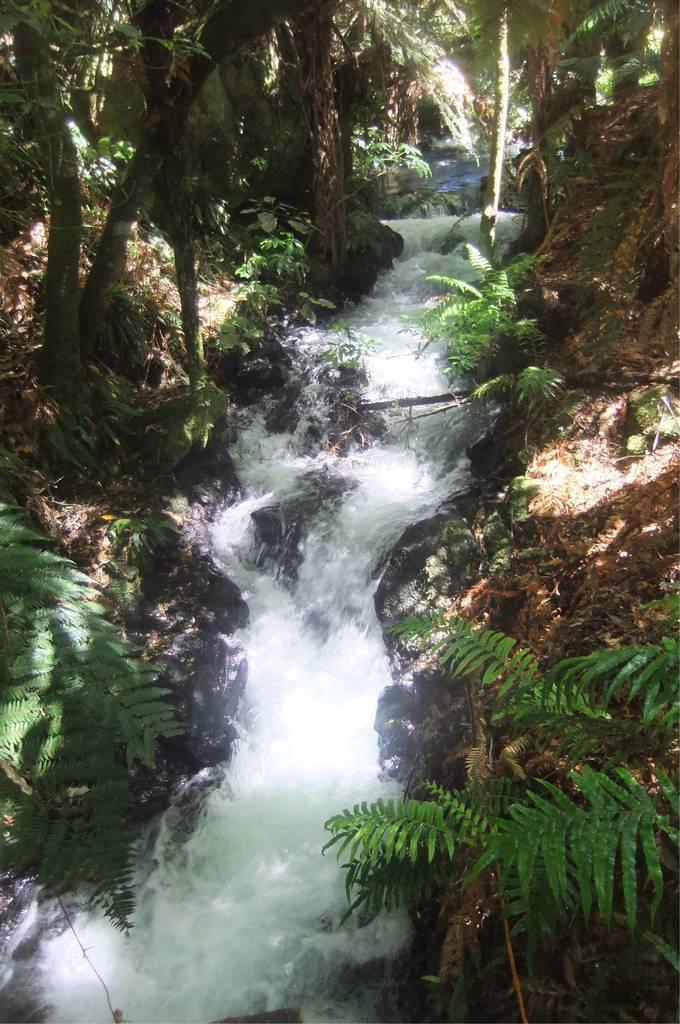Could you give a brief overview of what you see in this image? In the middle we can see water is flowing on the ground. To the either side of the water we can see trees on the ground. 